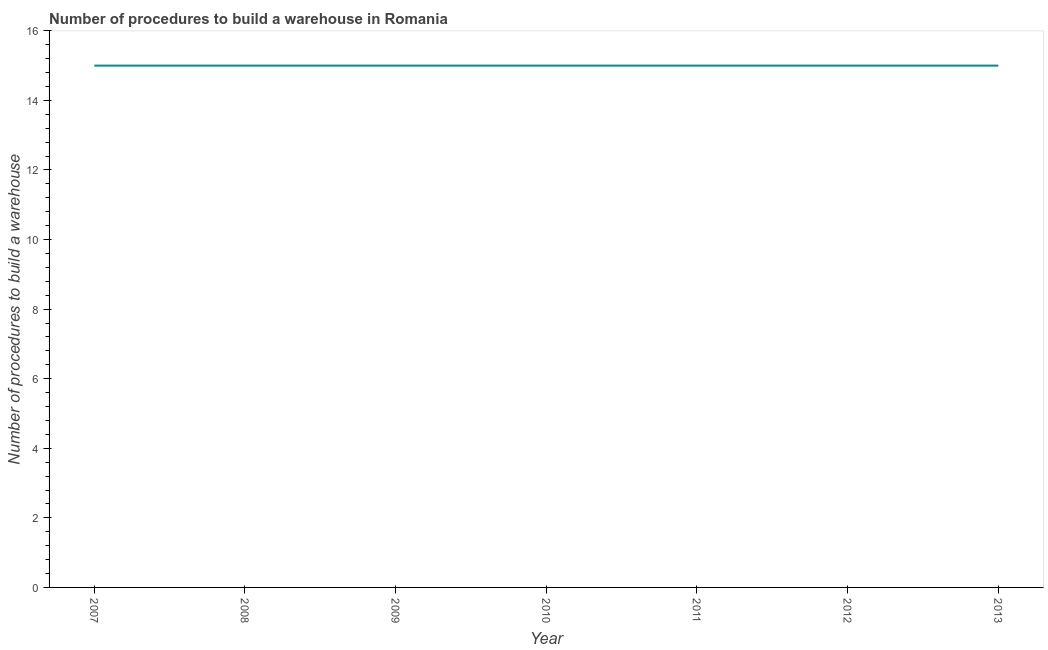What is the number of procedures to build a warehouse in 2008?
Ensure brevity in your answer.  15. Across all years, what is the maximum number of procedures to build a warehouse?
Make the answer very short. 15. Across all years, what is the minimum number of procedures to build a warehouse?
Make the answer very short. 15. What is the sum of the number of procedures to build a warehouse?
Offer a terse response. 105. In how many years, is the number of procedures to build a warehouse greater than 0.8 ?
Your answer should be very brief. 7. Do a majority of the years between 2009 and 2012 (inclusive) have number of procedures to build a warehouse greater than 7.2 ?
Give a very brief answer. Yes. What is the ratio of the number of procedures to build a warehouse in 2009 to that in 2012?
Give a very brief answer. 1. Is the number of procedures to build a warehouse in 2008 less than that in 2009?
Your answer should be very brief. No. What is the difference between the highest and the second highest number of procedures to build a warehouse?
Provide a short and direct response. 0. In how many years, is the number of procedures to build a warehouse greater than the average number of procedures to build a warehouse taken over all years?
Your answer should be compact. 0. Does the number of procedures to build a warehouse monotonically increase over the years?
Your answer should be very brief. No. How many lines are there?
Offer a terse response. 1. What is the difference between two consecutive major ticks on the Y-axis?
Your answer should be compact. 2. Does the graph contain any zero values?
Offer a very short reply. No. What is the title of the graph?
Offer a very short reply. Number of procedures to build a warehouse in Romania. What is the label or title of the X-axis?
Offer a terse response. Year. What is the label or title of the Y-axis?
Your answer should be very brief. Number of procedures to build a warehouse. What is the Number of procedures to build a warehouse of 2008?
Offer a terse response. 15. What is the Number of procedures to build a warehouse in 2011?
Your response must be concise. 15. What is the Number of procedures to build a warehouse of 2013?
Your answer should be compact. 15. What is the difference between the Number of procedures to build a warehouse in 2007 and 2009?
Provide a short and direct response. 0. What is the difference between the Number of procedures to build a warehouse in 2008 and 2009?
Provide a succinct answer. 0. What is the difference between the Number of procedures to build a warehouse in 2008 and 2010?
Offer a very short reply. 0. What is the difference between the Number of procedures to build a warehouse in 2008 and 2012?
Offer a terse response. 0. What is the difference between the Number of procedures to build a warehouse in 2008 and 2013?
Offer a very short reply. 0. What is the difference between the Number of procedures to build a warehouse in 2009 and 2010?
Keep it short and to the point. 0. What is the difference between the Number of procedures to build a warehouse in 2010 and 2013?
Keep it short and to the point. 0. What is the ratio of the Number of procedures to build a warehouse in 2007 to that in 2008?
Offer a very short reply. 1. What is the ratio of the Number of procedures to build a warehouse in 2007 to that in 2010?
Your answer should be very brief. 1. What is the ratio of the Number of procedures to build a warehouse in 2008 to that in 2011?
Provide a short and direct response. 1. What is the ratio of the Number of procedures to build a warehouse in 2008 to that in 2012?
Make the answer very short. 1. What is the ratio of the Number of procedures to build a warehouse in 2008 to that in 2013?
Offer a very short reply. 1. What is the ratio of the Number of procedures to build a warehouse in 2009 to that in 2011?
Your answer should be very brief. 1. What is the ratio of the Number of procedures to build a warehouse in 2010 to that in 2011?
Provide a succinct answer. 1. What is the ratio of the Number of procedures to build a warehouse in 2010 to that in 2012?
Your answer should be very brief. 1. What is the ratio of the Number of procedures to build a warehouse in 2011 to that in 2012?
Ensure brevity in your answer.  1. What is the ratio of the Number of procedures to build a warehouse in 2011 to that in 2013?
Make the answer very short. 1. What is the ratio of the Number of procedures to build a warehouse in 2012 to that in 2013?
Keep it short and to the point. 1. 